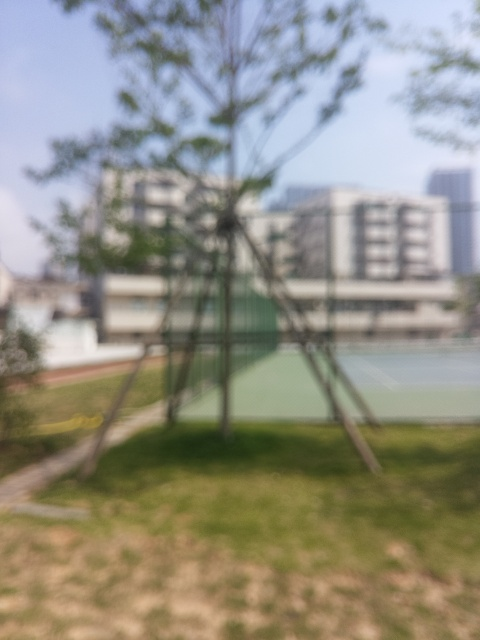What type of location is shown in the image? Although details are not clear due to the blurriness, the image seems to depict an outdoor area with greenery and possibly a sports court, suggesting a park or recreational facility. 